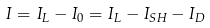<formula> <loc_0><loc_0><loc_500><loc_500>I = I _ { L } - I _ { 0 } = I _ { L } - I _ { S H } - I _ { D }</formula> 